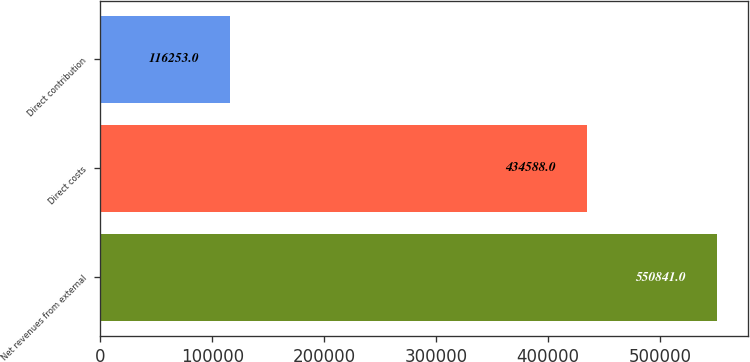Convert chart to OTSL. <chart><loc_0><loc_0><loc_500><loc_500><bar_chart><fcel>Net revenues from external<fcel>Direct costs<fcel>Direct contribution<nl><fcel>550841<fcel>434588<fcel>116253<nl></chart> 